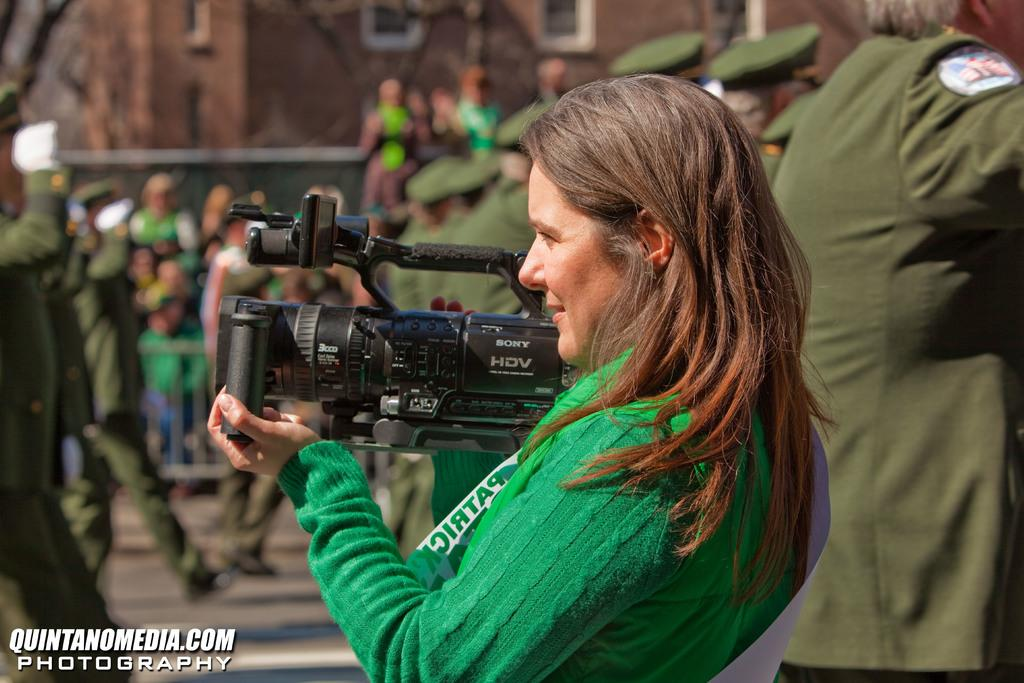What is the man in the image doing? The man is holding a camera in the image. How many people are present in the image? There are multiple people in the image. What can be seen in the background of the image? There is a building in the background of the image. What angle does the man need to drop the camera from in the image? There is no indication in the image that the man is dropping the camera, and therefore no angle is relevant. 